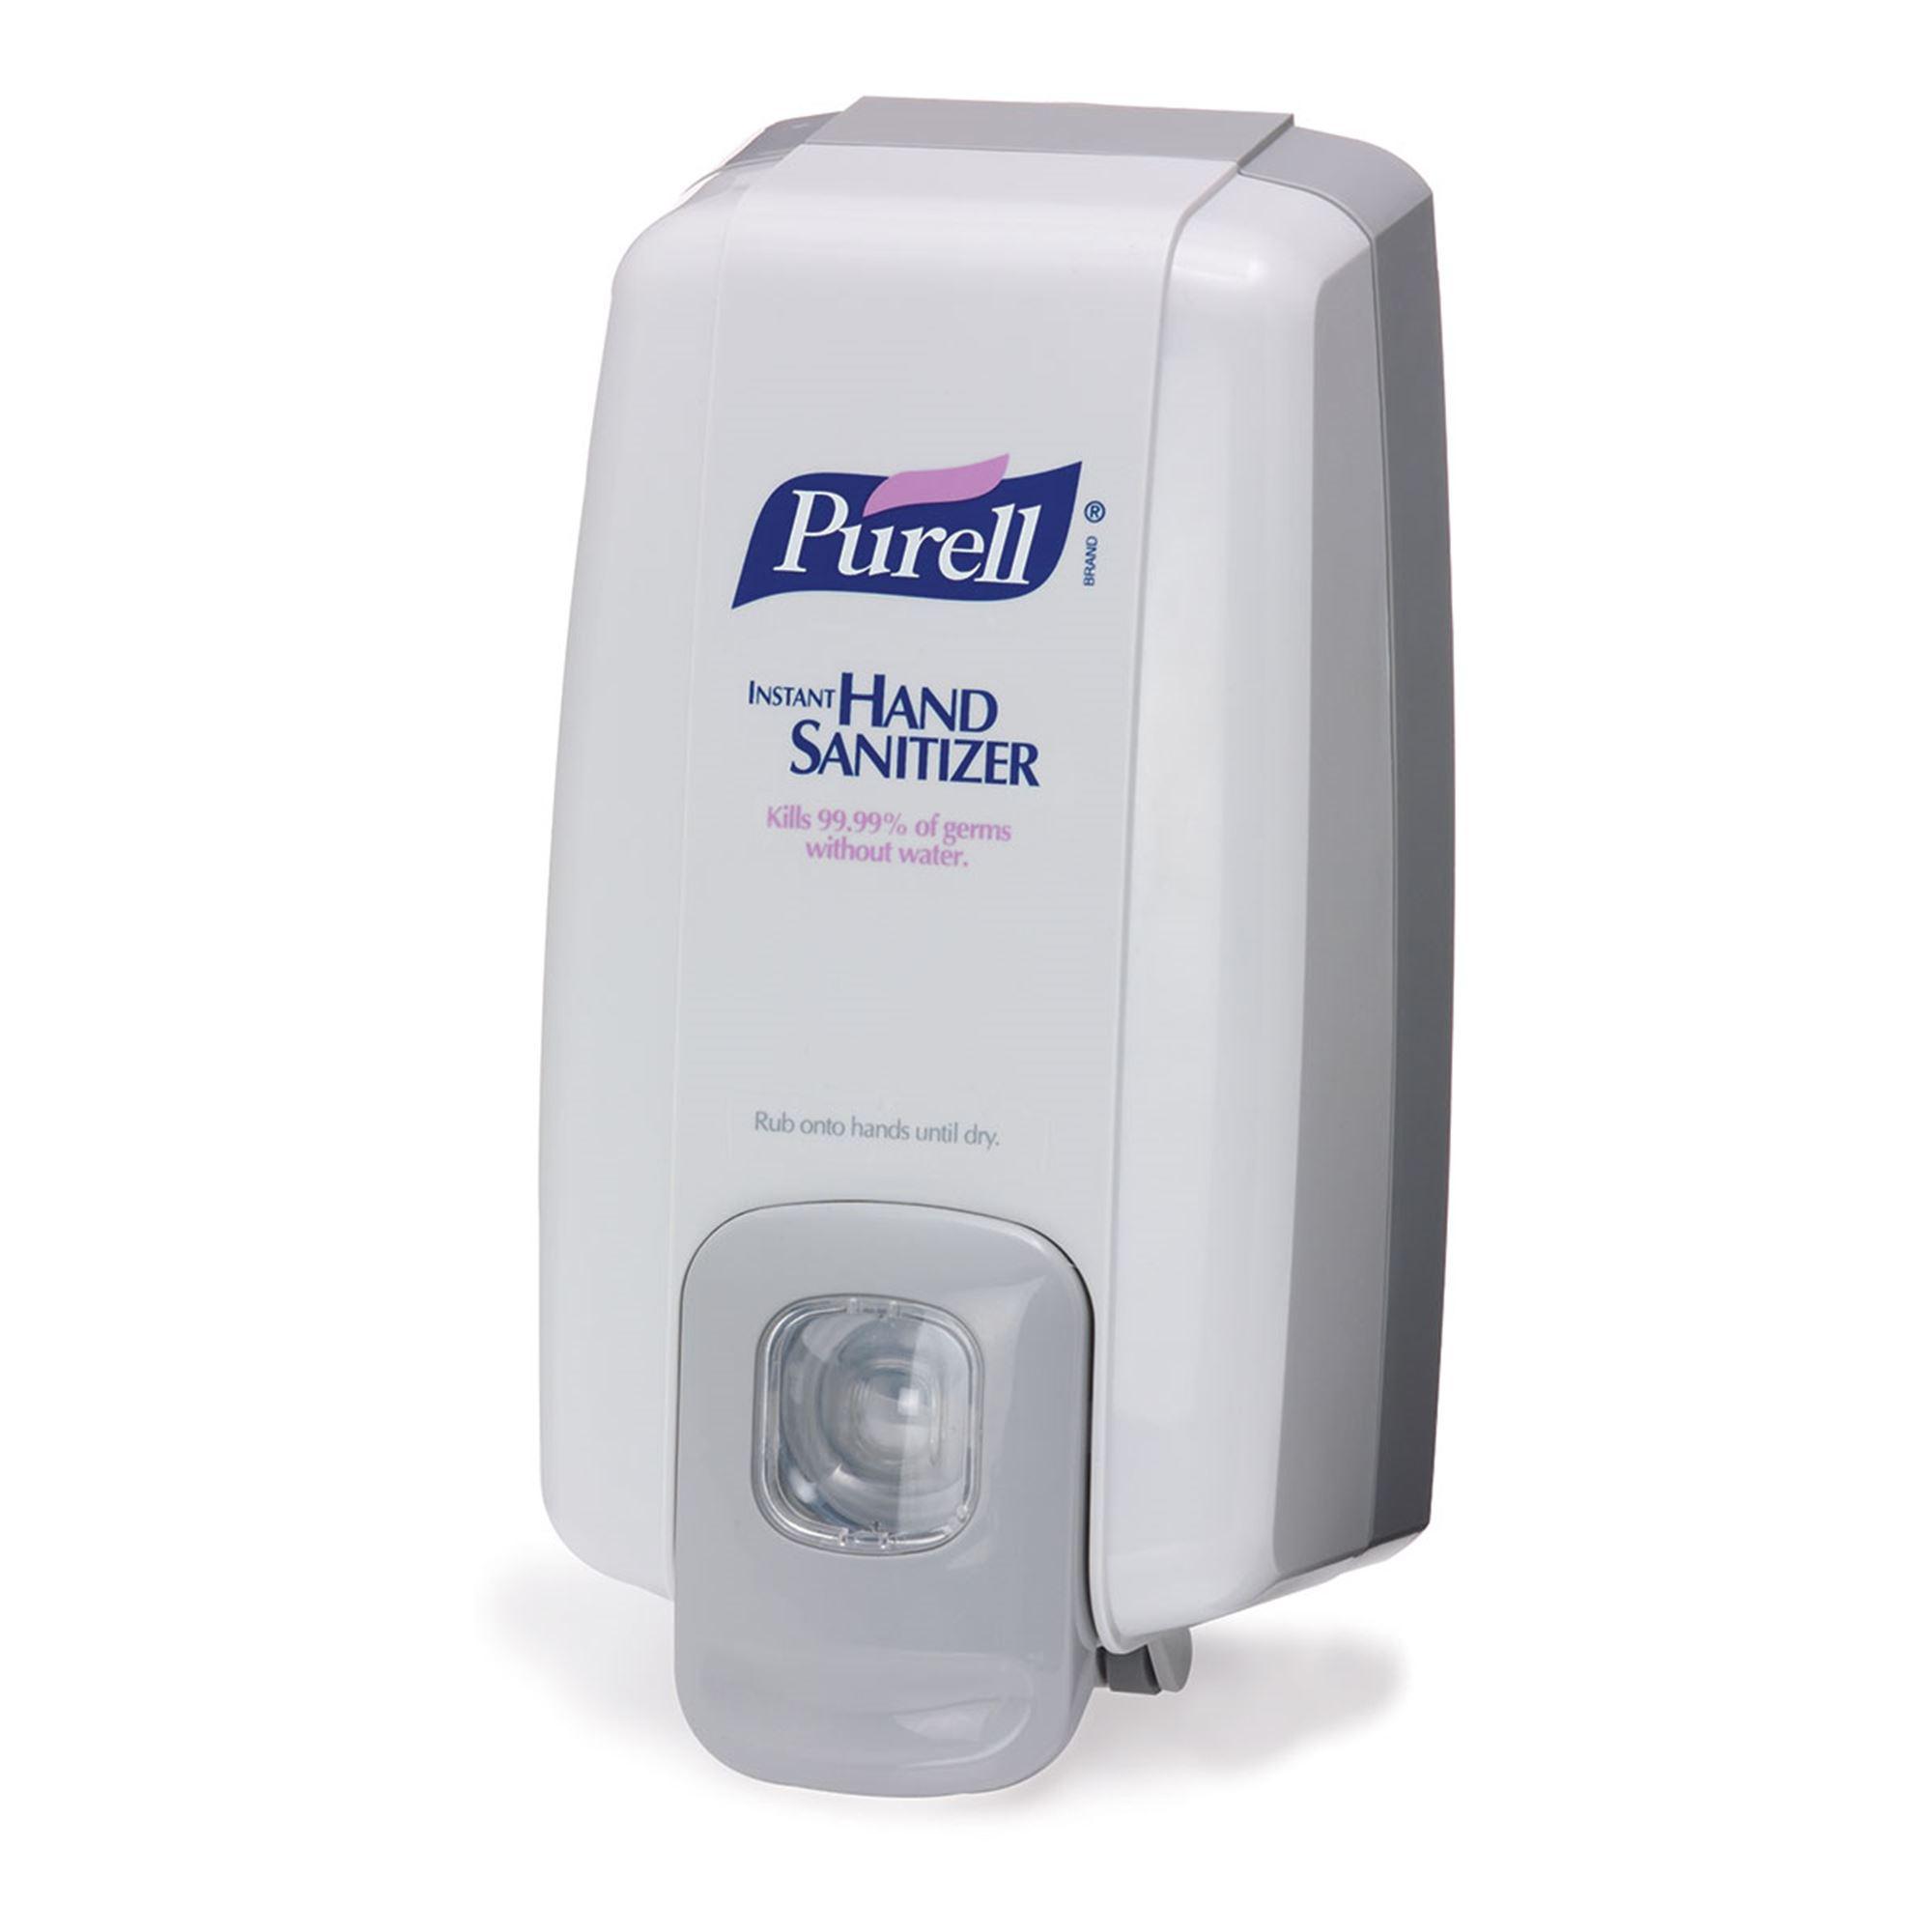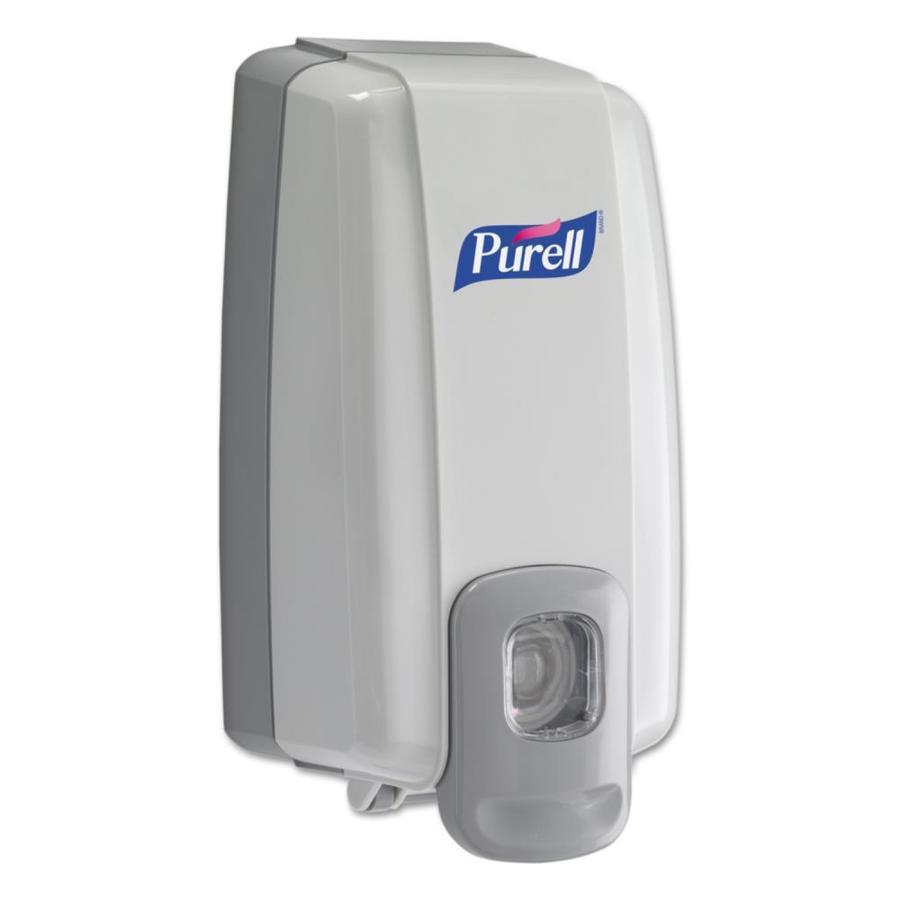The first image is the image on the left, the second image is the image on the right. Evaluate the accuracy of this statement regarding the images: "The combined images include a wall-mount dispenser, a horizontal nozzle, and at least one chrome element.". Is it true? Answer yes or no. No. The first image is the image on the left, the second image is the image on the right. Evaluate the accuracy of this statement regarding the images: "There are two white dispensers.". Is it true? Answer yes or no. Yes. 